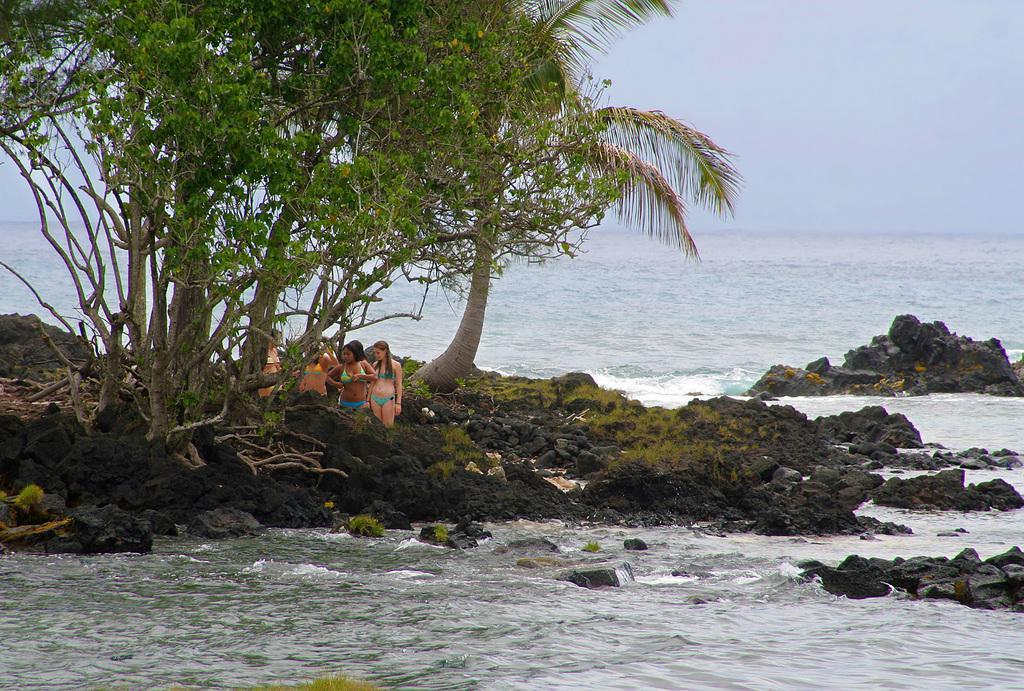How would you summarize this image in a sentence or two? As we can see in the image there is water, rocks, trees and group of people. At the top there is sky. 